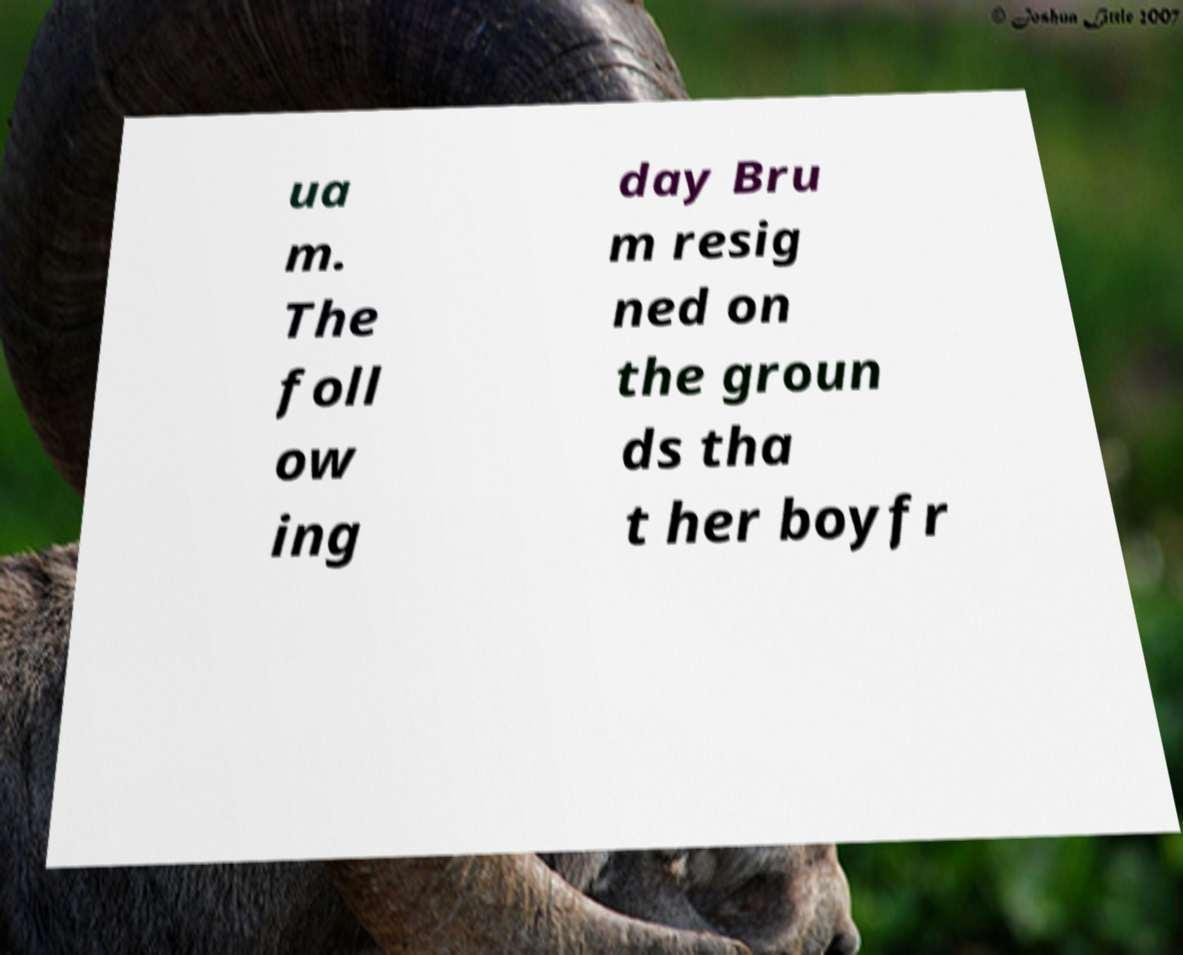There's text embedded in this image that I need extracted. Can you transcribe it verbatim? ua m. The foll ow ing day Bru m resig ned on the groun ds tha t her boyfr 